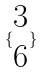Convert formula to latex. <formula><loc_0><loc_0><loc_500><loc_500>\{ \begin{matrix} 3 \\ 6 \end{matrix} \}</formula> 